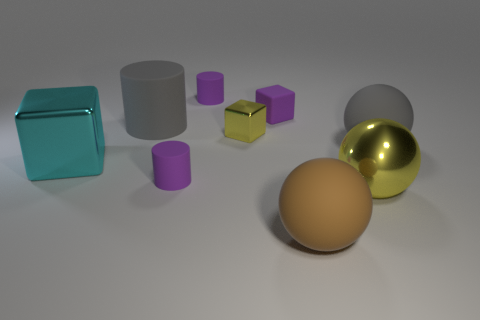Subtract all large gray rubber cylinders. How many cylinders are left? 2 Subtract all yellow spheres. How many purple cylinders are left? 2 Subtract 1 spheres. How many spheres are left? 2 Add 1 brown cubes. How many objects exist? 10 Subtract all green balls. Subtract all blue cylinders. How many balls are left? 3 Subtract all spheres. How many objects are left? 6 Subtract all metallic things. Subtract all big yellow metallic balls. How many objects are left? 5 Add 3 large matte cylinders. How many large matte cylinders are left? 4 Add 1 blue shiny cylinders. How many blue shiny cylinders exist? 1 Subtract 1 brown balls. How many objects are left? 8 